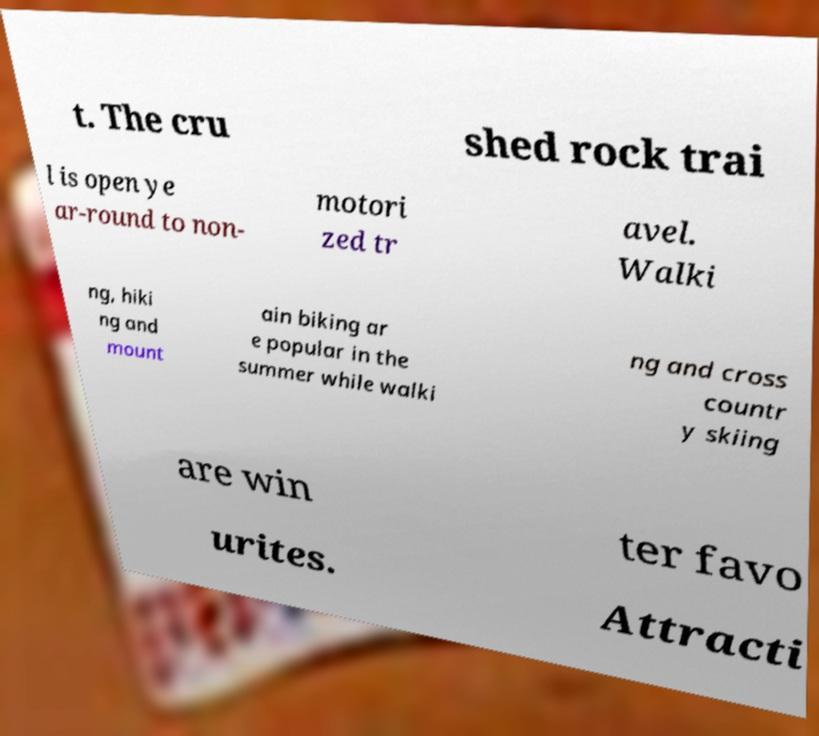Can you accurately transcribe the text from the provided image for me? t. The cru shed rock trai l is open ye ar-round to non- motori zed tr avel. Walki ng, hiki ng and mount ain biking ar e popular in the summer while walki ng and cross countr y skiing are win ter favo urites. Attracti 